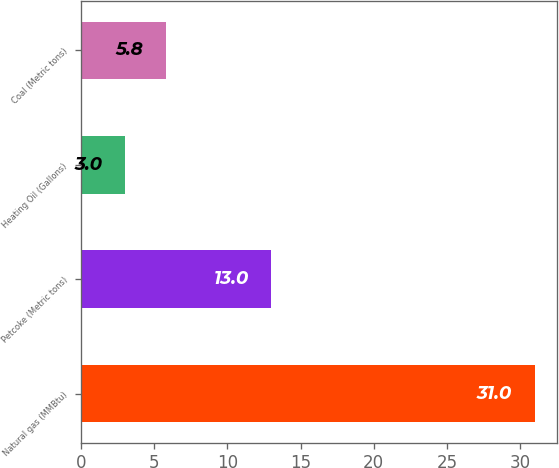<chart> <loc_0><loc_0><loc_500><loc_500><bar_chart><fcel>Natural gas (MMBtu)<fcel>Petcoke (Metric tons)<fcel>Heating Oil (Gallons)<fcel>Coal (Metric tons)<nl><fcel>31<fcel>13<fcel>3<fcel>5.8<nl></chart> 